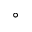<formula> <loc_0><loc_0><loc_500><loc_500>^ { \circ }</formula> 